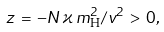Convert formula to latex. <formula><loc_0><loc_0><loc_500><loc_500>z \, = \, - N \, \varkappa \, m _ { \mathrm H } ^ { 2 } / v ^ { 2 } \, > \, 0 ,</formula> 